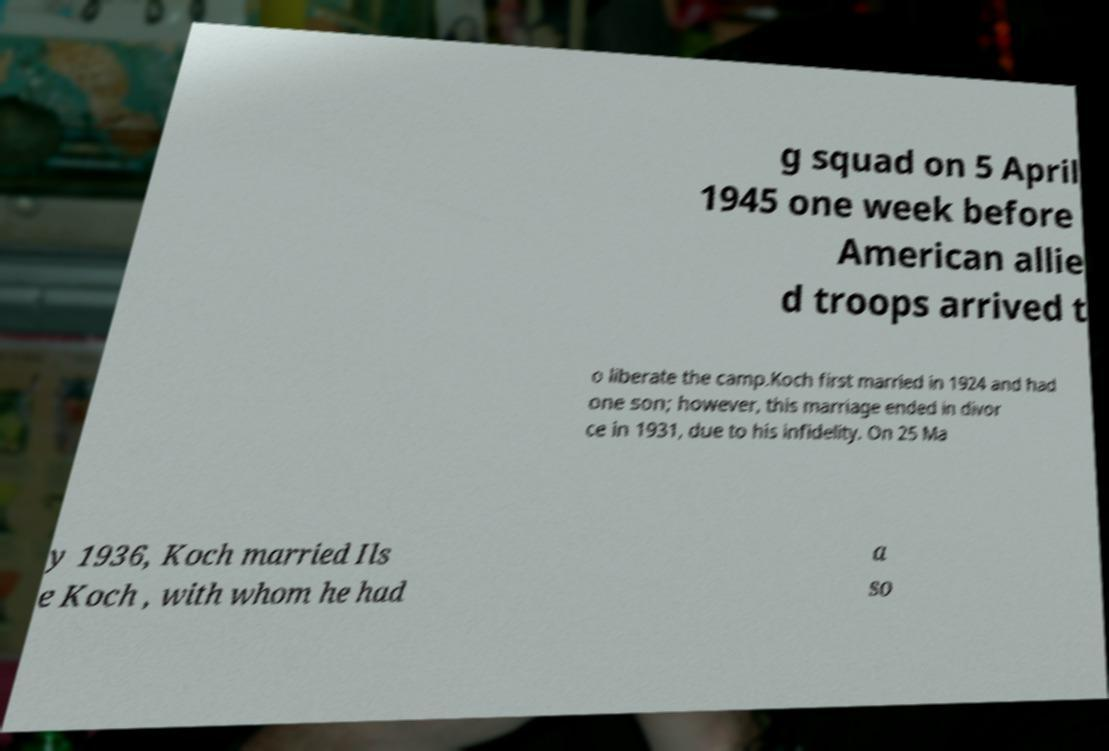Please read and relay the text visible in this image. What does it say? g squad on 5 April 1945 one week before American allie d troops arrived t o liberate the camp.Koch first married in 1924 and had one son; however, this marriage ended in divor ce in 1931, due to his infidelity. On 25 Ma y 1936, Koch married Ils e Koch , with whom he had a so 